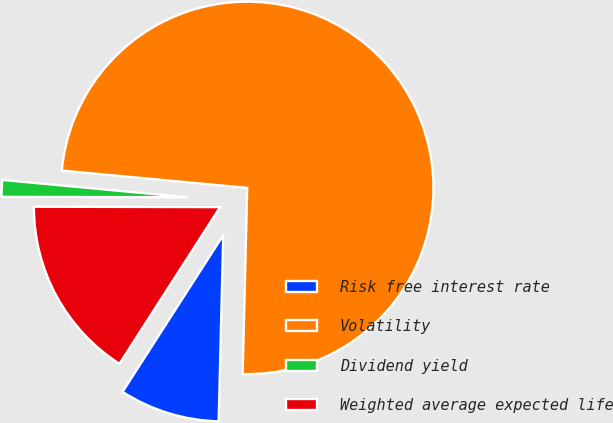<chart> <loc_0><loc_0><loc_500><loc_500><pie_chart><fcel>Risk free interest rate<fcel>Volatility<fcel>Dividend yield<fcel>Weighted average expected life<nl><fcel>8.7%<fcel>73.9%<fcel>1.45%<fcel>15.94%<nl></chart> 